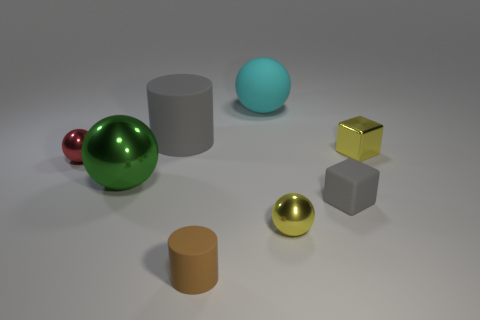Subtract all red balls. How many balls are left? 3 Subtract all green spheres. How many spheres are left? 3 Subtract all cubes. How many objects are left? 6 Add 2 red metal things. How many objects exist? 10 Add 4 big gray cylinders. How many big gray cylinders exist? 5 Subtract 1 yellow balls. How many objects are left? 7 Subtract all cyan balls. Subtract all green blocks. How many balls are left? 3 Subtract all small things. Subtract all tiny metal objects. How many objects are left? 0 Add 7 red spheres. How many red spheres are left? 8 